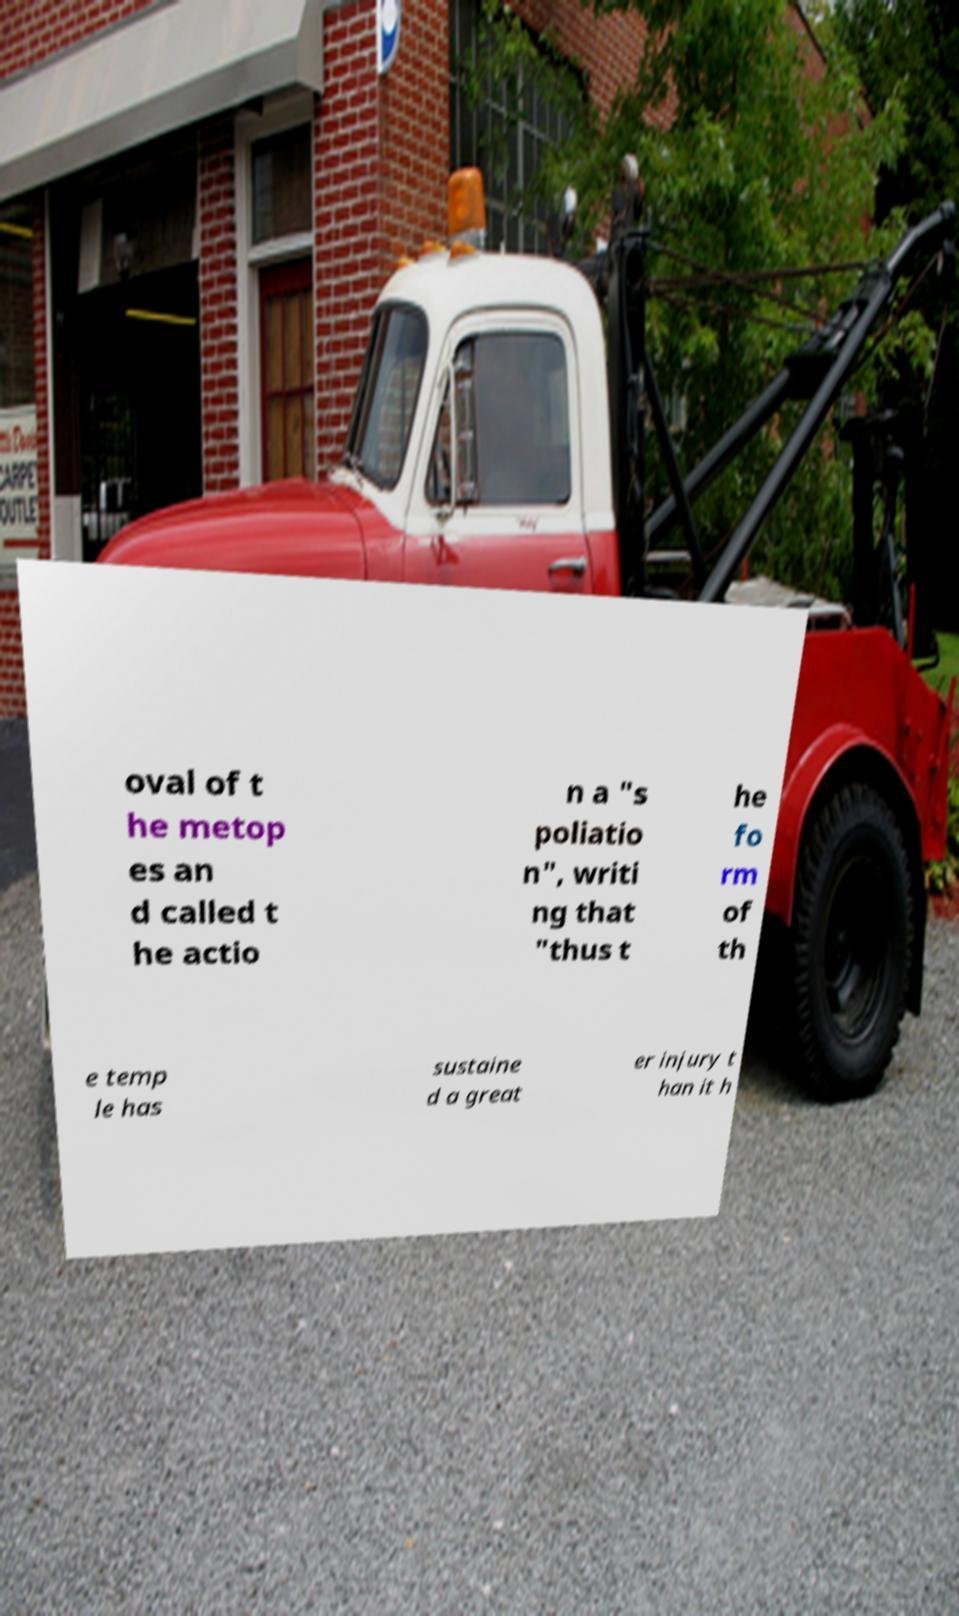Can you accurately transcribe the text from the provided image for me? oval of t he metop es an d called t he actio n a "s poliatio n", writi ng that "thus t he fo rm of th e temp le has sustaine d a great er injury t han it h 